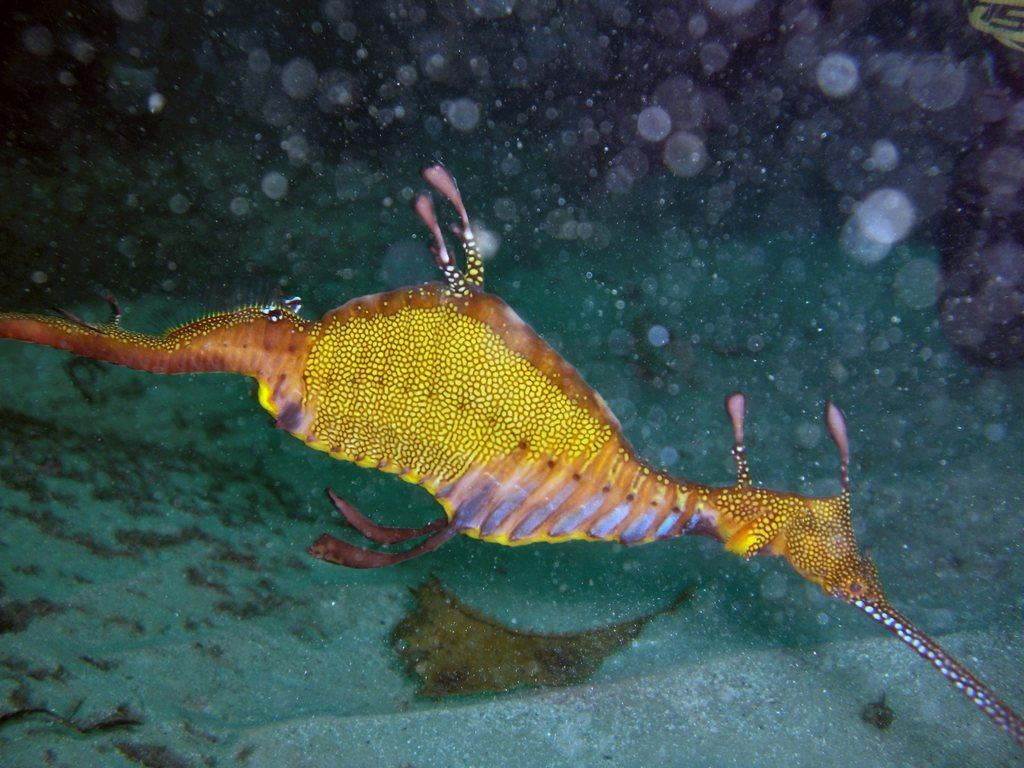What type of creature is in the image? There is a sea dragon in the image. Where is the sea dragon located? The sea dragon is in the water. What decision does the sea dragon make in the image? There is no indication in the image that the sea dragon is making a decision, as it is a creature and not capable of making decisions. 